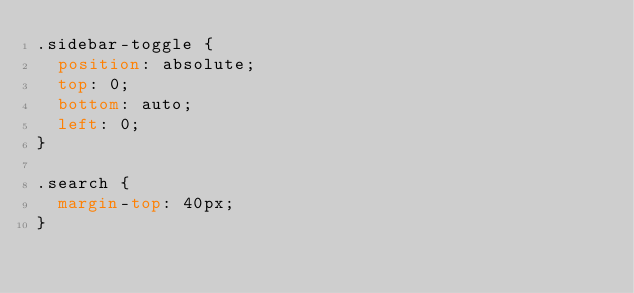<code> <loc_0><loc_0><loc_500><loc_500><_CSS_>.sidebar-toggle {
  position: absolute;
  top: 0;
  bottom: auto;
  left: 0;
}

.search {
  margin-top: 40px;
}

</code> 